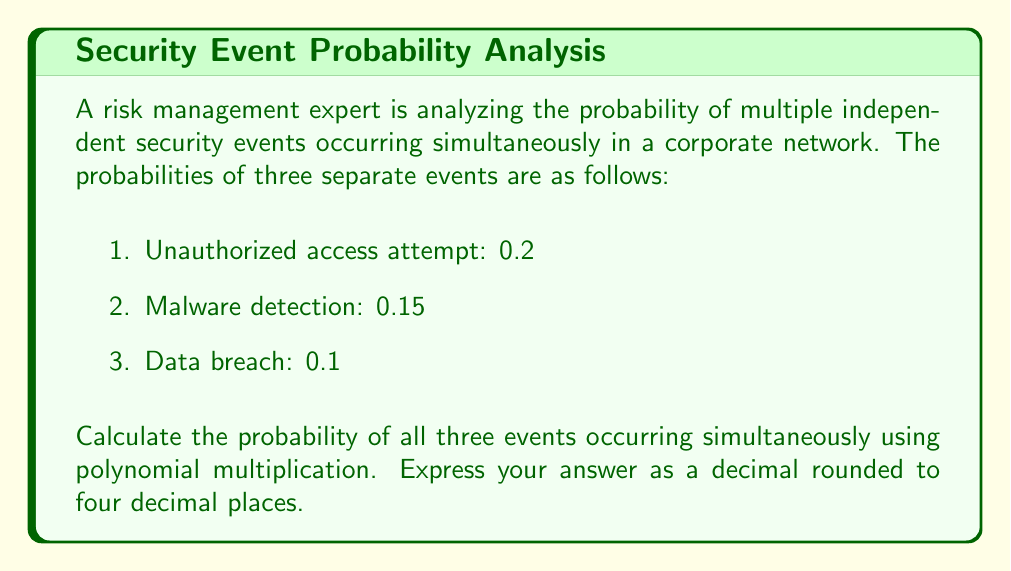Help me with this question. To solve this problem, we'll use polynomial multiplication to represent the probability of multiple independent events occurring simultaneously. Each event can be represented as a binomial, where the probability of occurrence is added to the probability of non-occurrence (which equals 1 minus the probability of occurrence).

Let's represent each event as a binomial:

1. Unauthorized access attempt: $$(0.2 + 0.8x)$$
2. Malware detection: $$(0.15 + 0.85x)$$
3. Data breach: $$(0.1 + 0.9x)$$

To find the probability of all events occurring simultaneously, we need to multiply these binomials:

$$(0.2 + 0.8x)(0.15 + 0.85x)(0.1 + 0.9x)$$

Expanding this product:

$$(0.2 + 0.8x)(0.15 + 0.85x) = 0.03 + 0.17x + 0.12x + 0.68x^2$$
$$= 0.03 + 0.29x + 0.68x^2$$

Now, multiply this result by the third binomial:

$$(0.03 + 0.29x + 0.68x^2)(0.1 + 0.9x)$$

$$= 0.003 + 0.027x + 0.029x + 0.261x^2 + 0.068x^2 + 0.612x^3$$

$$= 0.003 + 0.056x + 0.329x^2 + 0.612x^3$$

In this final polynomial, the constant term (0.003) represents the probability of all three events occurring simultaneously.
Answer: 0.0030 